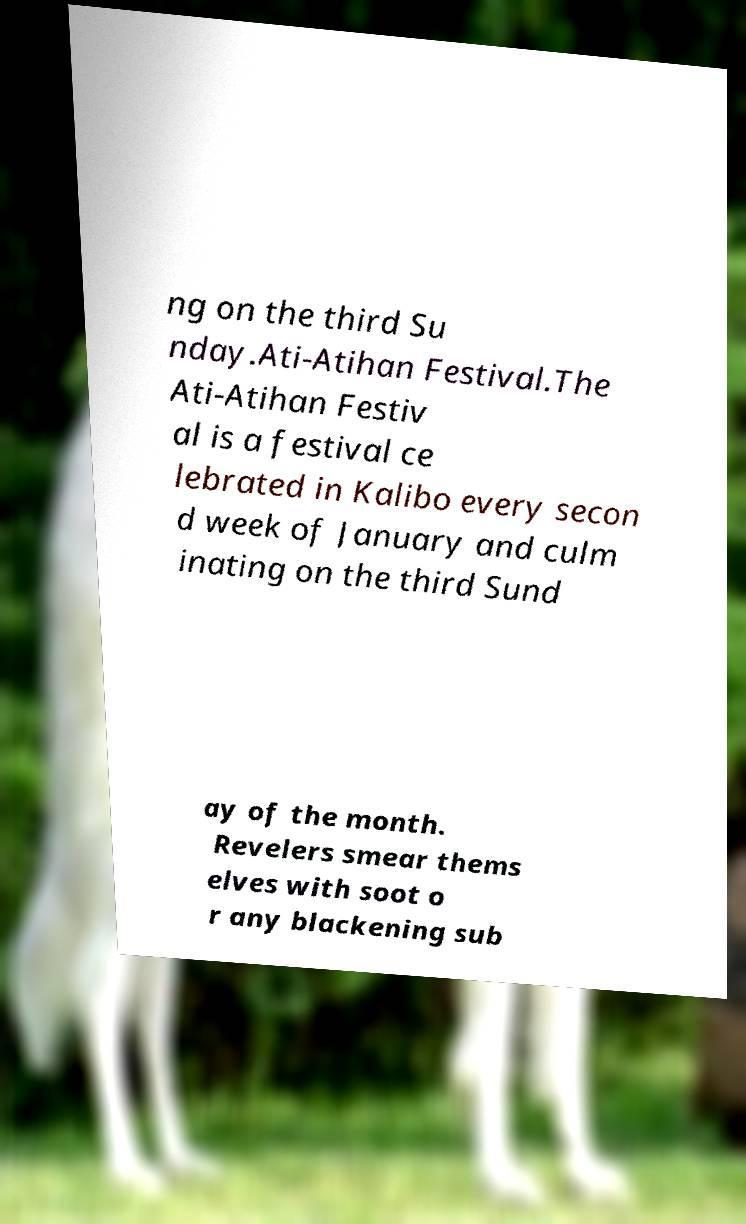Can you accurately transcribe the text from the provided image for me? ng on the third Su nday.Ati-Atihan Festival.The Ati-Atihan Festiv al is a festival ce lebrated in Kalibo every secon d week of January and culm inating on the third Sund ay of the month. Revelers smear thems elves with soot o r any blackening sub 